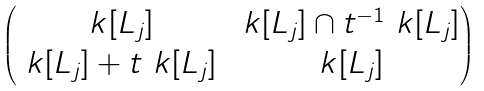<formula> <loc_0><loc_0><loc_500><loc_500>\begin{pmatrix} \ k [ L _ { j } ] & \ k [ L _ { j } ] \cap t ^ { - 1 } \ k [ L _ { j } ] \\ \ k [ L _ { j } ] + t \ k [ L _ { j } ] & \ k [ L _ { j } ] \end{pmatrix}</formula> 